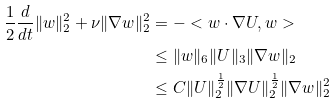Convert formula to latex. <formula><loc_0><loc_0><loc_500><loc_500>\frac { 1 } { 2 } \frac { d } { d t } \| w \| _ { 2 } ^ { 2 } + \nu \| \nabla w \| _ { 2 } ^ { 2 } & = - < w \cdot \nabla U , w > \\ & \leq \| w \| _ { 6 } \| U \| _ { 3 } \| \nabla w \| _ { 2 } \\ & \leq C \| U \| ^ { \frac { 1 } { 2 } } _ { 2 } \| \nabla U \| ^ { \frac { 1 } { 2 } } _ { 2 } \| \nabla w \| ^ { 2 } _ { 2 }</formula> 